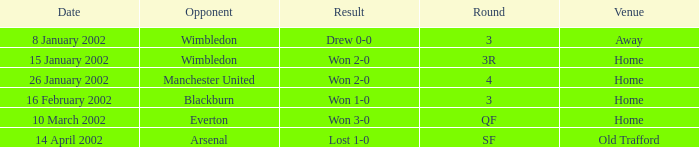Could you help me parse every detail presented in this table? {'header': ['Date', 'Opponent', 'Result', 'Round', 'Venue'], 'rows': [['8 January 2002', 'Wimbledon', 'Drew 0-0', '3', 'Away'], ['15 January 2002', 'Wimbledon', 'Won 2-0', '3R', 'Home'], ['26 January 2002', 'Manchester United', 'Won 2-0', '4', 'Home'], ['16 February 2002', 'Blackburn', 'Won 1-0', '3', 'Home'], ['10 March 2002', 'Everton', 'Won 3-0', 'QF', 'Home'], ['14 April 2002', 'Arsenal', 'Lost 1-0', 'SF', 'Old Trafford']]} What is the Venue with a Date with 14 april 2002? Old Trafford. 